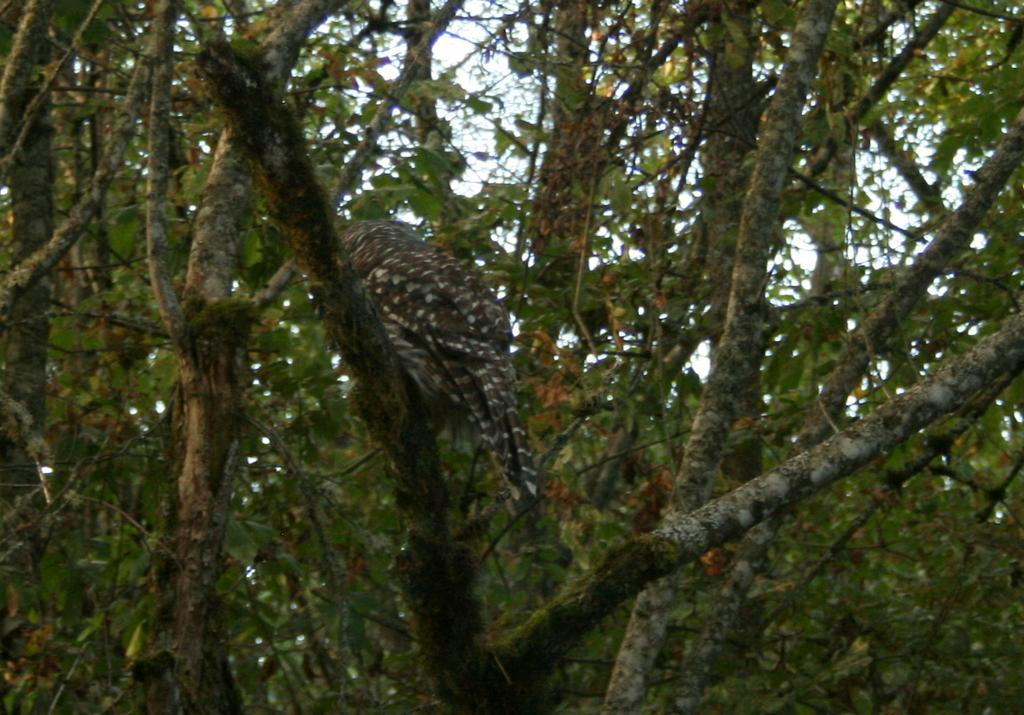What type of animal can be seen in the image? There is a bird on a tree in the image. What other objects or features can be seen in the image? There are trees visible in the image. What part of the natural environment is visible in the image? The sky is visible in the image. What type of pie is the bird eating in the image? There is no pie present in the image; it features a bird on a tree and trees in the background. 